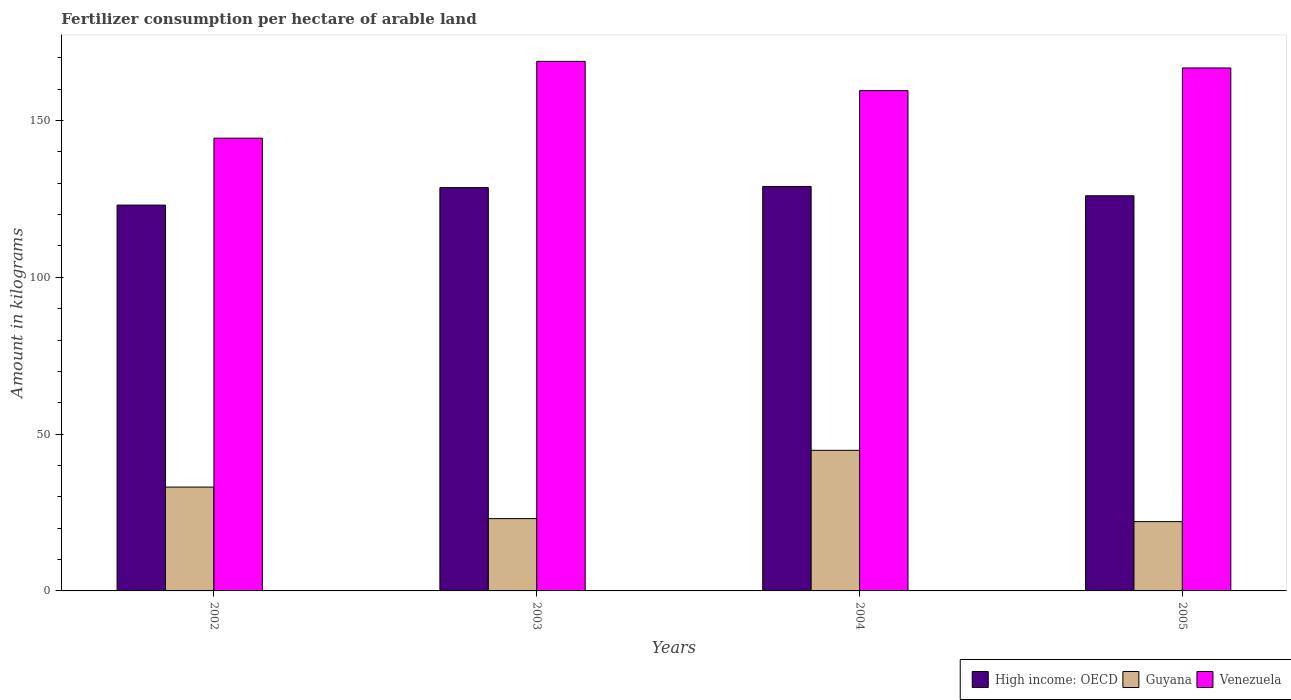Are the number of bars per tick equal to the number of legend labels?
Keep it short and to the point. Yes. Are the number of bars on each tick of the X-axis equal?
Offer a terse response. Yes. How many bars are there on the 1st tick from the left?
Your answer should be very brief. 3. What is the label of the 3rd group of bars from the left?
Offer a terse response. 2004. What is the amount of fertilizer consumption in Venezuela in 2005?
Your answer should be compact. 166.75. Across all years, what is the maximum amount of fertilizer consumption in Venezuela?
Provide a succinct answer. 168.86. Across all years, what is the minimum amount of fertilizer consumption in High income: OECD?
Offer a terse response. 123.02. In which year was the amount of fertilizer consumption in High income: OECD minimum?
Your answer should be compact. 2002. What is the total amount of fertilizer consumption in High income: OECD in the graph?
Offer a very short reply. 506.58. What is the difference between the amount of fertilizer consumption in High income: OECD in 2003 and that in 2005?
Provide a succinct answer. 2.6. What is the difference between the amount of fertilizer consumption in High income: OECD in 2003 and the amount of fertilizer consumption in Guyana in 2004?
Offer a terse response. 83.76. What is the average amount of fertilizer consumption in Venezuela per year?
Your answer should be very brief. 159.88. In the year 2003, what is the difference between the amount of fertilizer consumption in Venezuela and amount of fertilizer consumption in Guyana?
Offer a terse response. 145.8. In how many years, is the amount of fertilizer consumption in High income: OECD greater than 10 kg?
Ensure brevity in your answer.  4. What is the ratio of the amount of fertilizer consumption in High income: OECD in 2002 to that in 2005?
Your answer should be very brief. 0.98. Is the amount of fertilizer consumption in Guyana in 2002 less than that in 2004?
Keep it short and to the point. Yes. What is the difference between the highest and the second highest amount of fertilizer consumption in Guyana?
Make the answer very short. 11.72. What is the difference between the highest and the lowest amount of fertilizer consumption in High income: OECD?
Provide a short and direct response. 5.94. In how many years, is the amount of fertilizer consumption in High income: OECD greater than the average amount of fertilizer consumption in High income: OECD taken over all years?
Your answer should be very brief. 2. Is the sum of the amount of fertilizer consumption in High income: OECD in 2002 and 2005 greater than the maximum amount of fertilizer consumption in Venezuela across all years?
Provide a succinct answer. Yes. What does the 3rd bar from the left in 2003 represents?
Your answer should be very brief. Venezuela. What does the 3rd bar from the right in 2005 represents?
Offer a very short reply. High income: OECD. What is the difference between two consecutive major ticks on the Y-axis?
Your answer should be compact. 50. Does the graph contain any zero values?
Provide a short and direct response. No. Does the graph contain grids?
Your answer should be very brief. No. How many legend labels are there?
Your answer should be very brief. 3. What is the title of the graph?
Offer a terse response. Fertilizer consumption per hectare of arable land. What is the label or title of the Y-axis?
Your answer should be compact. Amount in kilograms. What is the Amount in kilograms of High income: OECD in 2002?
Keep it short and to the point. 123.02. What is the Amount in kilograms of Guyana in 2002?
Offer a very short reply. 33.11. What is the Amount in kilograms of Venezuela in 2002?
Offer a very short reply. 144.37. What is the Amount in kilograms of High income: OECD in 2003?
Offer a very short reply. 128.59. What is the Amount in kilograms of Guyana in 2003?
Offer a terse response. 23.06. What is the Amount in kilograms in Venezuela in 2003?
Offer a terse response. 168.86. What is the Amount in kilograms of High income: OECD in 2004?
Ensure brevity in your answer.  128.97. What is the Amount in kilograms in Guyana in 2004?
Offer a very short reply. 44.83. What is the Amount in kilograms in Venezuela in 2004?
Your response must be concise. 159.53. What is the Amount in kilograms in High income: OECD in 2005?
Offer a very short reply. 126. What is the Amount in kilograms in Guyana in 2005?
Your response must be concise. 22.1. What is the Amount in kilograms in Venezuela in 2005?
Provide a succinct answer. 166.75. Across all years, what is the maximum Amount in kilograms of High income: OECD?
Your response must be concise. 128.97. Across all years, what is the maximum Amount in kilograms in Guyana?
Give a very brief answer. 44.83. Across all years, what is the maximum Amount in kilograms in Venezuela?
Your answer should be compact. 168.86. Across all years, what is the minimum Amount in kilograms of High income: OECD?
Keep it short and to the point. 123.02. Across all years, what is the minimum Amount in kilograms of Guyana?
Your answer should be compact. 22.1. Across all years, what is the minimum Amount in kilograms of Venezuela?
Your answer should be compact. 144.37. What is the total Amount in kilograms of High income: OECD in the graph?
Provide a short and direct response. 506.58. What is the total Amount in kilograms in Guyana in the graph?
Make the answer very short. 123.1. What is the total Amount in kilograms of Venezuela in the graph?
Offer a very short reply. 639.52. What is the difference between the Amount in kilograms of High income: OECD in 2002 and that in 2003?
Your response must be concise. -5.57. What is the difference between the Amount in kilograms in Guyana in 2002 and that in 2003?
Your answer should be very brief. 10.06. What is the difference between the Amount in kilograms of Venezuela in 2002 and that in 2003?
Your answer should be compact. -24.49. What is the difference between the Amount in kilograms in High income: OECD in 2002 and that in 2004?
Your answer should be compact. -5.94. What is the difference between the Amount in kilograms in Guyana in 2002 and that in 2004?
Provide a succinct answer. -11.72. What is the difference between the Amount in kilograms in Venezuela in 2002 and that in 2004?
Make the answer very short. -15.16. What is the difference between the Amount in kilograms in High income: OECD in 2002 and that in 2005?
Offer a very short reply. -2.97. What is the difference between the Amount in kilograms in Guyana in 2002 and that in 2005?
Provide a short and direct response. 11.01. What is the difference between the Amount in kilograms in Venezuela in 2002 and that in 2005?
Your answer should be very brief. -22.38. What is the difference between the Amount in kilograms of High income: OECD in 2003 and that in 2004?
Offer a terse response. -0.37. What is the difference between the Amount in kilograms in Guyana in 2003 and that in 2004?
Provide a short and direct response. -21.78. What is the difference between the Amount in kilograms of Venezuela in 2003 and that in 2004?
Provide a succinct answer. 9.33. What is the difference between the Amount in kilograms of High income: OECD in 2003 and that in 2005?
Make the answer very short. 2.6. What is the difference between the Amount in kilograms of Guyana in 2003 and that in 2005?
Provide a short and direct response. 0.96. What is the difference between the Amount in kilograms of Venezuela in 2003 and that in 2005?
Your answer should be very brief. 2.11. What is the difference between the Amount in kilograms in High income: OECD in 2004 and that in 2005?
Your answer should be compact. 2.97. What is the difference between the Amount in kilograms of Guyana in 2004 and that in 2005?
Your answer should be compact. 22.74. What is the difference between the Amount in kilograms in Venezuela in 2004 and that in 2005?
Your response must be concise. -7.22. What is the difference between the Amount in kilograms in High income: OECD in 2002 and the Amount in kilograms in Guyana in 2003?
Offer a terse response. 99.97. What is the difference between the Amount in kilograms of High income: OECD in 2002 and the Amount in kilograms of Venezuela in 2003?
Offer a very short reply. -45.84. What is the difference between the Amount in kilograms in Guyana in 2002 and the Amount in kilograms in Venezuela in 2003?
Give a very brief answer. -135.75. What is the difference between the Amount in kilograms of High income: OECD in 2002 and the Amount in kilograms of Guyana in 2004?
Offer a terse response. 78.19. What is the difference between the Amount in kilograms in High income: OECD in 2002 and the Amount in kilograms in Venezuela in 2004?
Provide a short and direct response. -36.51. What is the difference between the Amount in kilograms in Guyana in 2002 and the Amount in kilograms in Venezuela in 2004?
Your response must be concise. -126.42. What is the difference between the Amount in kilograms of High income: OECD in 2002 and the Amount in kilograms of Guyana in 2005?
Your response must be concise. 100.93. What is the difference between the Amount in kilograms of High income: OECD in 2002 and the Amount in kilograms of Venezuela in 2005?
Your response must be concise. -43.73. What is the difference between the Amount in kilograms in Guyana in 2002 and the Amount in kilograms in Venezuela in 2005?
Make the answer very short. -133.64. What is the difference between the Amount in kilograms in High income: OECD in 2003 and the Amount in kilograms in Guyana in 2004?
Provide a succinct answer. 83.76. What is the difference between the Amount in kilograms in High income: OECD in 2003 and the Amount in kilograms in Venezuela in 2004?
Give a very brief answer. -30.94. What is the difference between the Amount in kilograms in Guyana in 2003 and the Amount in kilograms in Venezuela in 2004?
Your answer should be compact. -136.48. What is the difference between the Amount in kilograms in High income: OECD in 2003 and the Amount in kilograms in Guyana in 2005?
Make the answer very short. 106.5. What is the difference between the Amount in kilograms in High income: OECD in 2003 and the Amount in kilograms in Venezuela in 2005?
Your answer should be very brief. -38.16. What is the difference between the Amount in kilograms in Guyana in 2003 and the Amount in kilograms in Venezuela in 2005?
Ensure brevity in your answer.  -143.7. What is the difference between the Amount in kilograms in High income: OECD in 2004 and the Amount in kilograms in Guyana in 2005?
Your response must be concise. 106.87. What is the difference between the Amount in kilograms of High income: OECD in 2004 and the Amount in kilograms of Venezuela in 2005?
Ensure brevity in your answer.  -37.78. What is the difference between the Amount in kilograms of Guyana in 2004 and the Amount in kilograms of Venezuela in 2005?
Provide a succinct answer. -121.92. What is the average Amount in kilograms in High income: OECD per year?
Give a very brief answer. 126.65. What is the average Amount in kilograms in Guyana per year?
Provide a succinct answer. 30.77. What is the average Amount in kilograms in Venezuela per year?
Provide a succinct answer. 159.88. In the year 2002, what is the difference between the Amount in kilograms of High income: OECD and Amount in kilograms of Guyana?
Provide a short and direct response. 89.91. In the year 2002, what is the difference between the Amount in kilograms of High income: OECD and Amount in kilograms of Venezuela?
Provide a succinct answer. -21.35. In the year 2002, what is the difference between the Amount in kilograms in Guyana and Amount in kilograms in Venezuela?
Keep it short and to the point. -111.26. In the year 2003, what is the difference between the Amount in kilograms in High income: OECD and Amount in kilograms in Guyana?
Your answer should be compact. 105.54. In the year 2003, what is the difference between the Amount in kilograms of High income: OECD and Amount in kilograms of Venezuela?
Give a very brief answer. -40.27. In the year 2003, what is the difference between the Amount in kilograms in Guyana and Amount in kilograms in Venezuela?
Provide a short and direct response. -145.8. In the year 2004, what is the difference between the Amount in kilograms in High income: OECD and Amount in kilograms in Guyana?
Ensure brevity in your answer.  84.13. In the year 2004, what is the difference between the Amount in kilograms of High income: OECD and Amount in kilograms of Venezuela?
Provide a short and direct response. -30.57. In the year 2004, what is the difference between the Amount in kilograms of Guyana and Amount in kilograms of Venezuela?
Give a very brief answer. -114.7. In the year 2005, what is the difference between the Amount in kilograms of High income: OECD and Amount in kilograms of Guyana?
Your response must be concise. 103.9. In the year 2005, what is the difference between the Amount in kilograms of High income: OECD and Amount in kilograms of Venezuela?
Offer a very short reply. -40.75. In the year 2005, what is the difference between the Amount in kilograms in Guyana and Amount in kilograms in Venezuela?
Give a very brief answer. -144.65. What is the ratio of the Amount in kilograms in High income: OECD in 2002 to that in 2003?
Your response must be concise. 0.96. What is the ratio of the Amount in kilograms of Guyana in 2002 to that in 2003?
Ensure brevity in your answer.  1.44. What is the ratio of the Amount in kilograms in Venezuela in 2002 to that in 2003?
Keep it short and to the point. 0.85. What is the ratio of the Amount in kilograms of High income: OECD in 2002 to that in 2004?
Your response must be concise. 0.95. What is the ratio of the Amount in kilograms in Guyana in 2002 to that in 2004?
Provide a short and direct response. 0.74. What is the ratio of the Amount in kilograms in Venezuela in 2002 to that in 2004?
Keep it short and to the point. 0.9. What is the ratio of the Amount in kilograms of High income: OECD in 2002 to that in 2005?
Make the answer very short. 0.98. What is the ratio of the Amount in kilograms in Guyana in 2002 to that in 2005?
Your answer should be very brief. 1.5. What is the ratio of the Amount in kilograms of Venezuela in 2002 to that in 2005?
Give a very brief answer. 0.87. What is the ratio of the Amount in kilograms in Guyana in 2003 to that in 2004?
Provide a succinct answer. 0.51. What is the ratio of the Amount in kilograms of Venezuela in 2003 to that in 2004?
Make the answer very short. 1.06. What is the ratio of the Amount in kilograms in High income: OECD in 2003 to that in 2005?
Your answer should be compact. 1.02. What is the ratio of the Amount in kilograms of Guyana in 2003 to that in 2005?
Offer a terse response. 1.04. What is the ratio of the Amount in kilograms of Venezuela in 2003 to that in 2005?
Give a very brief answer. 1.01. What is the ratio of the Amount in kilograms in High income: OECD in 2004 to that in 2005?
Offer a terse response. 1.02. What is the ratio of the Amount in kilograms in Guyana in 2004 to that in 2005?
Give a very brief answer. 2.03. What is the ratio of the Amount in kilograms in Venezuela in 2004 to that in 2005?
Your answer should be compact. 0.96. What is the difference between the highest and the second highest Amount in kilograms in High income: OECD?
Provide a short and direct response. 0.37. What is the difference between the highest and the second highest Amount in kilograms in Guyana?
Provide a short and direct response. 11.72. What is the difference between the highest and the second highest Amount in kilograms of Venezuela?
Offer a very short reply. 2.11. What is the difference between the highest and the lowest Amount in kilograms of High income: OECD?
Provide a short and direct response. 5.94. What is the difference between the highest and the lowest Amount in kilograms of Guyana?
Ensure brevity in your answer.  22.74. What is the difference between the highest and the lowest Amount in kilograms of Venezuela?
Provide a short and direct response. 24.49. 